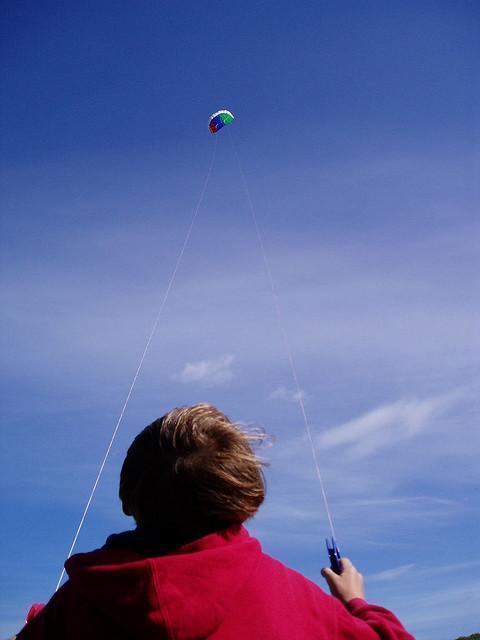How many strings are attached to the kite?
Give a very brief answer. 2. How many full red umbrellas are visible in the image?
Give a very brief answer. 0. 